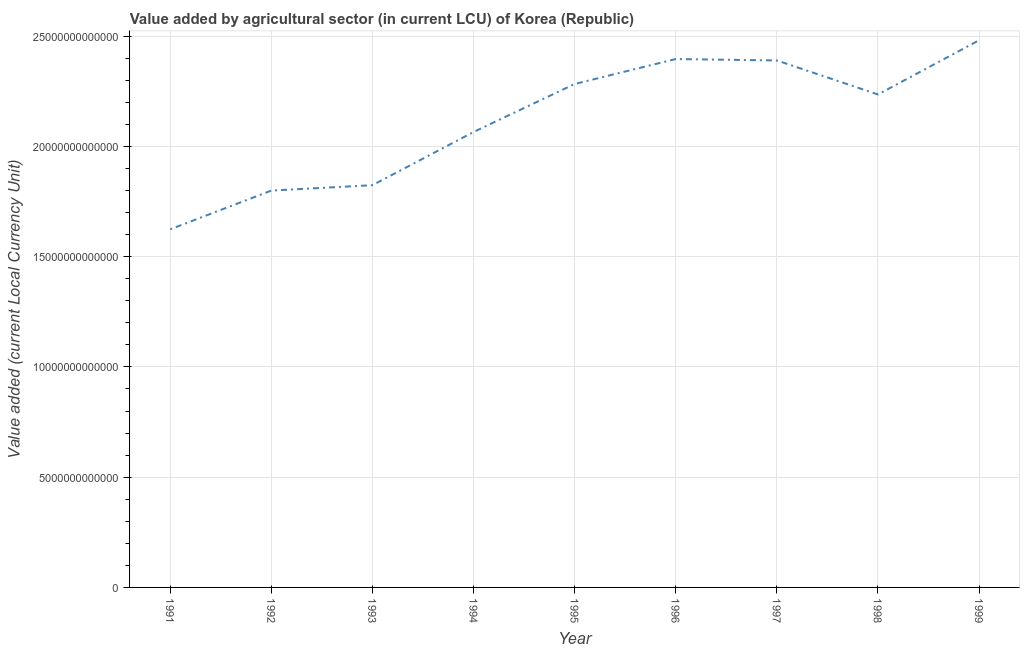What is the value added by agriculture sector in 1999?
Give a very brief answer. 2.48e+13. Across all years, what is the maximum value added by agriculture sector?
Give a very brief answer. 2.48e+13. Across all years, what is the minimum value added by agriculture sector?
Make the answer very short. 1.62e+13. In which year was the value added by agriculture sector maximum?
Provide a succinct answer. 1999. In which year was the value added by agriculture sector minimum?
Give a very brief answer. 1991. What is the sum of the value added by agriculture sector?
Your response must be concise. 1.91e+14. What is the difference between the value added by agriculture sector in 1991 and 1992?
Ensure brevity in your answer.  -1.76e+12. What is the average value added by agriculture sector per year?
Your answer should be very brief. 2.12e+13. What is the median value added by agriculture sector?
Your response must be concise. 2.24e+13. Do a majority of the years between 1994 and 1993 (inclusive) have value added by agriculture sector greater than 4000000000000 LCU?
Provide a succinct answer. No. What is the ratio of the value added by agriculture sector in 1994 to that in 1999?
Make the answer very short. 0.83. Is the difference between the value added by agriculture sector in 1997 and 1999 greater than the difference between any two years?
Provide a short and direct response. No. What is the difference between the highest and the second highest value added by agriculture sector?
Provide a succinct answer. 8.51e+11. Is the sum of the value added by agriculture sector in 1993 and 1999 greater than the maximum value added by agriculture sector across all years?
Your answer should be very brief. Yes. What is the difference between the highest and the lowest value added by agriculture sector?
Offer a very short reply. 8.57e+12. How many years are there in the graph?
Your response must be concise. 9. What is the difference between two consecutive major ticks on the Y-axis?
Your answer should be very brief. 5.00e+12. Does the graph contain any zero values?
Ensure brevity in your answer.  No. What is the title of the graph?
Provide a short and direct response. Value added by agricultural sector (in current LCU) of Korea (Republic). What is the label or title of the Y-axis?
Offer a very short reply. Value added (current Local Currency Unit). What is the Value added (current Local Currency Unit) in 1991?
Ensure brevity in your answer.  1.62e+13. What is the Value added (current Local Currency Unit) in 1992?
Your response must be concise. 1.80e+13. What is the Value added (current Local Currency Unit) of 1993?
Make the answer very short. 1.82e+13. What is the Value added (current Local Currency Unit) of 1994?
Ensure brevity in your answer.  2.07e+13. What is the Value added (current Local Currency Unit) in 1995?
Provide a succinct answer. 2.28e+13. What is the Value added (current Local Currency Unit) in 1996?
Provide a succinct answer. 2.40e+13. What is the Value added (current Local Currency Unit) in 1997?
Your response must be concise. 2.39e+13. What is the Value added (current Local Currency Unit) in 1998?
Ensure brevity in your answer.  2.24e+13. What is the Value added (current Local Currency Unit) of 1999?
Offer a very short reply. 2.48e+13. What is the difference between the Value added (current Local Currency Unit) in 1991 and 1992?
Make the answer very short. -1.76e+12. What is the difference between the Value added (current Local Currency Unit) in 1991 and 1993?
Offer a terse response. -2.00e+12. What is the difference between the Value added (current Local Currency Unit) in 1991 and 1994?
Provide a succinct answer. -4.41e+12. What is the difference between the Value added (current Local Currency Unit) in 1991 and 1995?
Offer a very short reply. -6.59e+12. What is the difference between the Value added (current Local Currency Unit) in 1991 and 1996?
Your response must be concise. -7.72e+12. What is the difference between the Value added (current Local Currency Unit) in 1991 and 1997?
Provide a short and direct response. -7.66e+12. What is the difference between the Value added (current Local Currency Unit) in 1991 and 1998?
Offer a terse response. -6.12e+12. What is the difference between the Value added (current Local Currency Unit) in 1991 and 1999?
Offer a very short reply. -8.57e+12. What is the difference between the Value added (current Local Currency Unit) in 1992 and 1993?
Make the answer very short. -2.45e+11. What is the difference between the Value added (current Local Currency Unit) in 1992 and 1994?
Your answer should be compact. -2.66e+12. What is the difference between the Value added (current Local Currency Unit) in 1992 and 1995?
Keep it short and to the point. -4.83e+12. What is the difference between the Value added (current Local Currency Unit) in 1992 and 1996?
Your response must be concise. -5.97e+12. What is the difference between the Value added (current Local Currency Unit) in 1992 and 1997?
Make the answer very short. -5.90e+12. What is the difference between the Value added (current Local Currency Unit) in 1992 and 1998?
Keep it short and to the point. -4.36e+12. What is the difference between the Value added (current Local Currency Unit) in 1992 and 1999?
Your response must be concise. -6.82e+12. What is the difference between the Value added (current Local Currency Unit) in 1993 and 1994?
Provide a succinct answer. -2.41e+12. What is the difference between the Value added (current Local Currency Unit) in 1993 and 1995?
Give a very brief answer. -4.59e+12. What is the difference between the Value added (current Local Currency Unit) in 1993 and 1996?
Offer a very short reply. -5.72e+12. What is the difference between the Value added (current Local Currency Unit) in 1993 and 1997?
Provide a short and direct response. -5.66e+12. What is the difference between the Value added (current Local Currency Unit) in 1993 and 1998?
Provide a succinct answer. -4.11e+12. What is the difference between the Value added (current Local Currency Unit) in 1993 and 1999?
Make the answer very short. -6.57e+12. What is the difference between the Value added (current Local Currency Unit) in 1994 and 1995?
Ensure brevity in your answer.  -2.18e+12. What is the difference between the Value added (current Local Currency Unit) in 1994 and 1996?
Give a very brief answer. -3.31e+12. What is the difference between the Value added (current Local Currency Unit) in 1994 and 1997?
Provide a short and direct response. -3.24e+12. What is the difference between the Value added (current Local Currency Unit) in 1994 and 1998?
Make the answer very short. -1.70e+12. What is the difference between the Value added (current Local Currency Unit) in 1994 and 1999?
Make the answer very short. -4.16e+12. What is the difference between the Value added (current Local Currency Unit) in 1995 and 1996?
Your answer should be compact. -1.13e+12. What is the difference between the Value added (current Local Currency Unit) in 1995 and 1997?
Your answer should be compact. -1.07e+12. What is the difference between the Value added (current Local Currency Unit) in 1995 and 1998?
Your response must be concise. 4.74e+11. What is the difference between the Value added (current Local Currency Unit) in 1995 and 1999?
Your response must be concise. -1.98e+12. What is the difference between the Value added (current Local Currency Unit) in 1996 and 1997?
Provide a succinct answer. 6.52e+1. What is the difference between the Value added (current Local Currency Unit) in 1996 and 1998?
Ensure brevity in your answer.  1.61e+12. What is the difference between the Value added (current Local Currency Unit) in 1996 and 1999?
Your answer should be very brief. -8.51e+11. What is the difference between the Value added (current Local Currency Unit) in 1997 and 1998?
Provide a short and direct response. 1.54e+12. What is the difference between the Value added (current Local Currency Unit) in 1997 and 1999?
Your answer should be very brief. -9.16e+11. What is the difference between the Value added (current Local Currency Unit) in 1998 and 1999?
Keep it short and to the point. -2.46e+12. What is the ratio of the Value added (current Local Currency Unit) in 1991 to that in 1992?
Provide a short and direct response. 0.9. What is the ratio of the Value added (current Local Currency Unit) in 1991 to that in 1993?
Your response must be concise. 0.89. What is the ratio of the Value added (current Local Currency Unit) in 1991 to that in 1994?
Your answer should be compact. 0.79. What is the ratio of the Value added (current Local Currency Unit) in 1991 to that in 1995?
Make the answer very short. 0.71. What is the ratio of the Value added (current Local Currency Unit) in 1991 to that in 1996?
Give a very brief answer. 0.68. What is the ratio of the Value added (current Local Currency Unit) in 1991 to that in 1997?
Make the answer very short. 0.68. What is the ratio of the Value added (current Local Currency Unit) in 1991 to that in 1998?
Your response must be concise. 0.73. What is the ratio of the Value added (current Local Currency Unit) in 1991 to that in 1999?
Offer a terse response. 0.66. What is the ratio of the Value added (current Local Currency Unit) in 1992 to that in 1994?
Provide a short and direct response. 0.87. What is the ratio of the Value added (current Local Currency Unit) in 1992 to that in 1995?
Keep it short and to the point. 0.79. What is the ratio of the Value added (current Local Currency Unit) in 1992 to that in 1996?
Offer a very short reply. 0.75. What is the ratio of the Value added (current Local Currency Unit) in 1992 to that in 1997?
Keep it short and to the point. 0.75. What is the ratio of the Value added (current Local Currency Unit) in 1992 to that in 1998?
Your answer should be compact. 0.81. What is the ratio of the Value added (current Local Currency Unit) in 1992 to that in 1999?
Your answer should be compact. 0.72. What is the ratio of the Value added (current Local Currency Unit) in 1993 to that in 1994?
Ensure brevity in your answer.  0.88. What is the ratio of the Value added (current Local Currency Unit) in 1993 to that in 1995?
Offer a very short reply. 0.8. What is the ratio of the Value added (current Local Currency Unit) in 1993 to that in 1996?
Your answer should be very brief. 0.76. What is the ratio of the Value added (current Local Currency Unit) in 1993 to that in 1997?
Offer a very short reply. 0.76. What is the ratio of the Value added (current Local Currency Unit) in 1993 to that in 1998?
Ensure brevity in your answer.  0.82. What is the ratio of the Value added (current Local Currency Unit) in 1993 to that in 1999?
Your answer should be compact. 0.73. What is the ratio of the Value added (current Local Currency Unit) in 1994 to that in 1995?
Your response must be concise. 0.91. What is the ratio of the Value added (current Local Currency Unit) in 1994 to that in 1996?
Give a very brief answer. 0.86. What is the ratio of the Value added (current Local Currency Unit) in 1994 to that in 1997?
Offer a terse response. 0.86. What is the ratio of the Value added (current Local Currency Unit) in 1994 to that in 1998?
Give a very brief answer. 0.92. What is the ratio of the Value added (current Local Currency Unit) in 1994 to that in 1999?
Provide a succinct answer. 0.83. What is the ratio of the Value added (current Local Currency Unit) in 1995 to that in 1996?
Provide a short and direct response. 0.95. What is the ratio of the Value added (current Local Currency Unit) in 1995 to that in 1997?
Ensure brevity in your answer.  0.95. What is the ratio of the Value added (current Local Currency Unit) in 1996 to that in 1998?
Give a very brief answer. 1.07. What is the ratio of the Value added (current Local Currency Unit) in 1996 to that in 1999?
Provide a succinct answer. 0.97. What is the ratio of the Value added (current Local Currency Unit) in 1997 to that in 1998?
Your answer should be very brief. 1.07. What is the ratio of the Value added (current Local Currency Unit) in 1998 to that in 1999?
Ensure brevity in your answer.  0.9. 